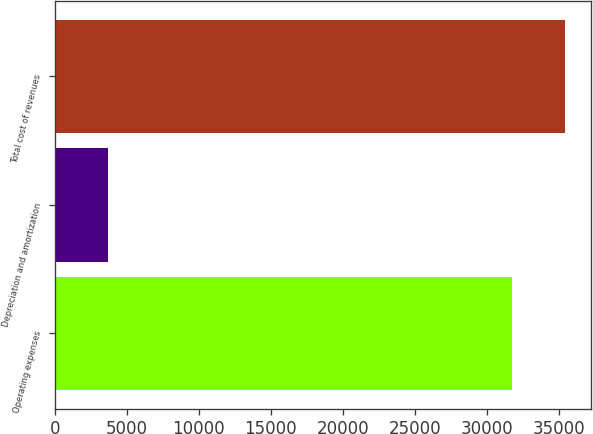Convert chart to OTSL. <chart><loc_0><loc_0><loc_500><loc_500><bar_chart><fcel>Operating expenses<fcel>Depreciation and amortization<fcel>Total cost of revenues<nl><fcel>31790<fcel>3683<fcel>35473<nl></chart> 